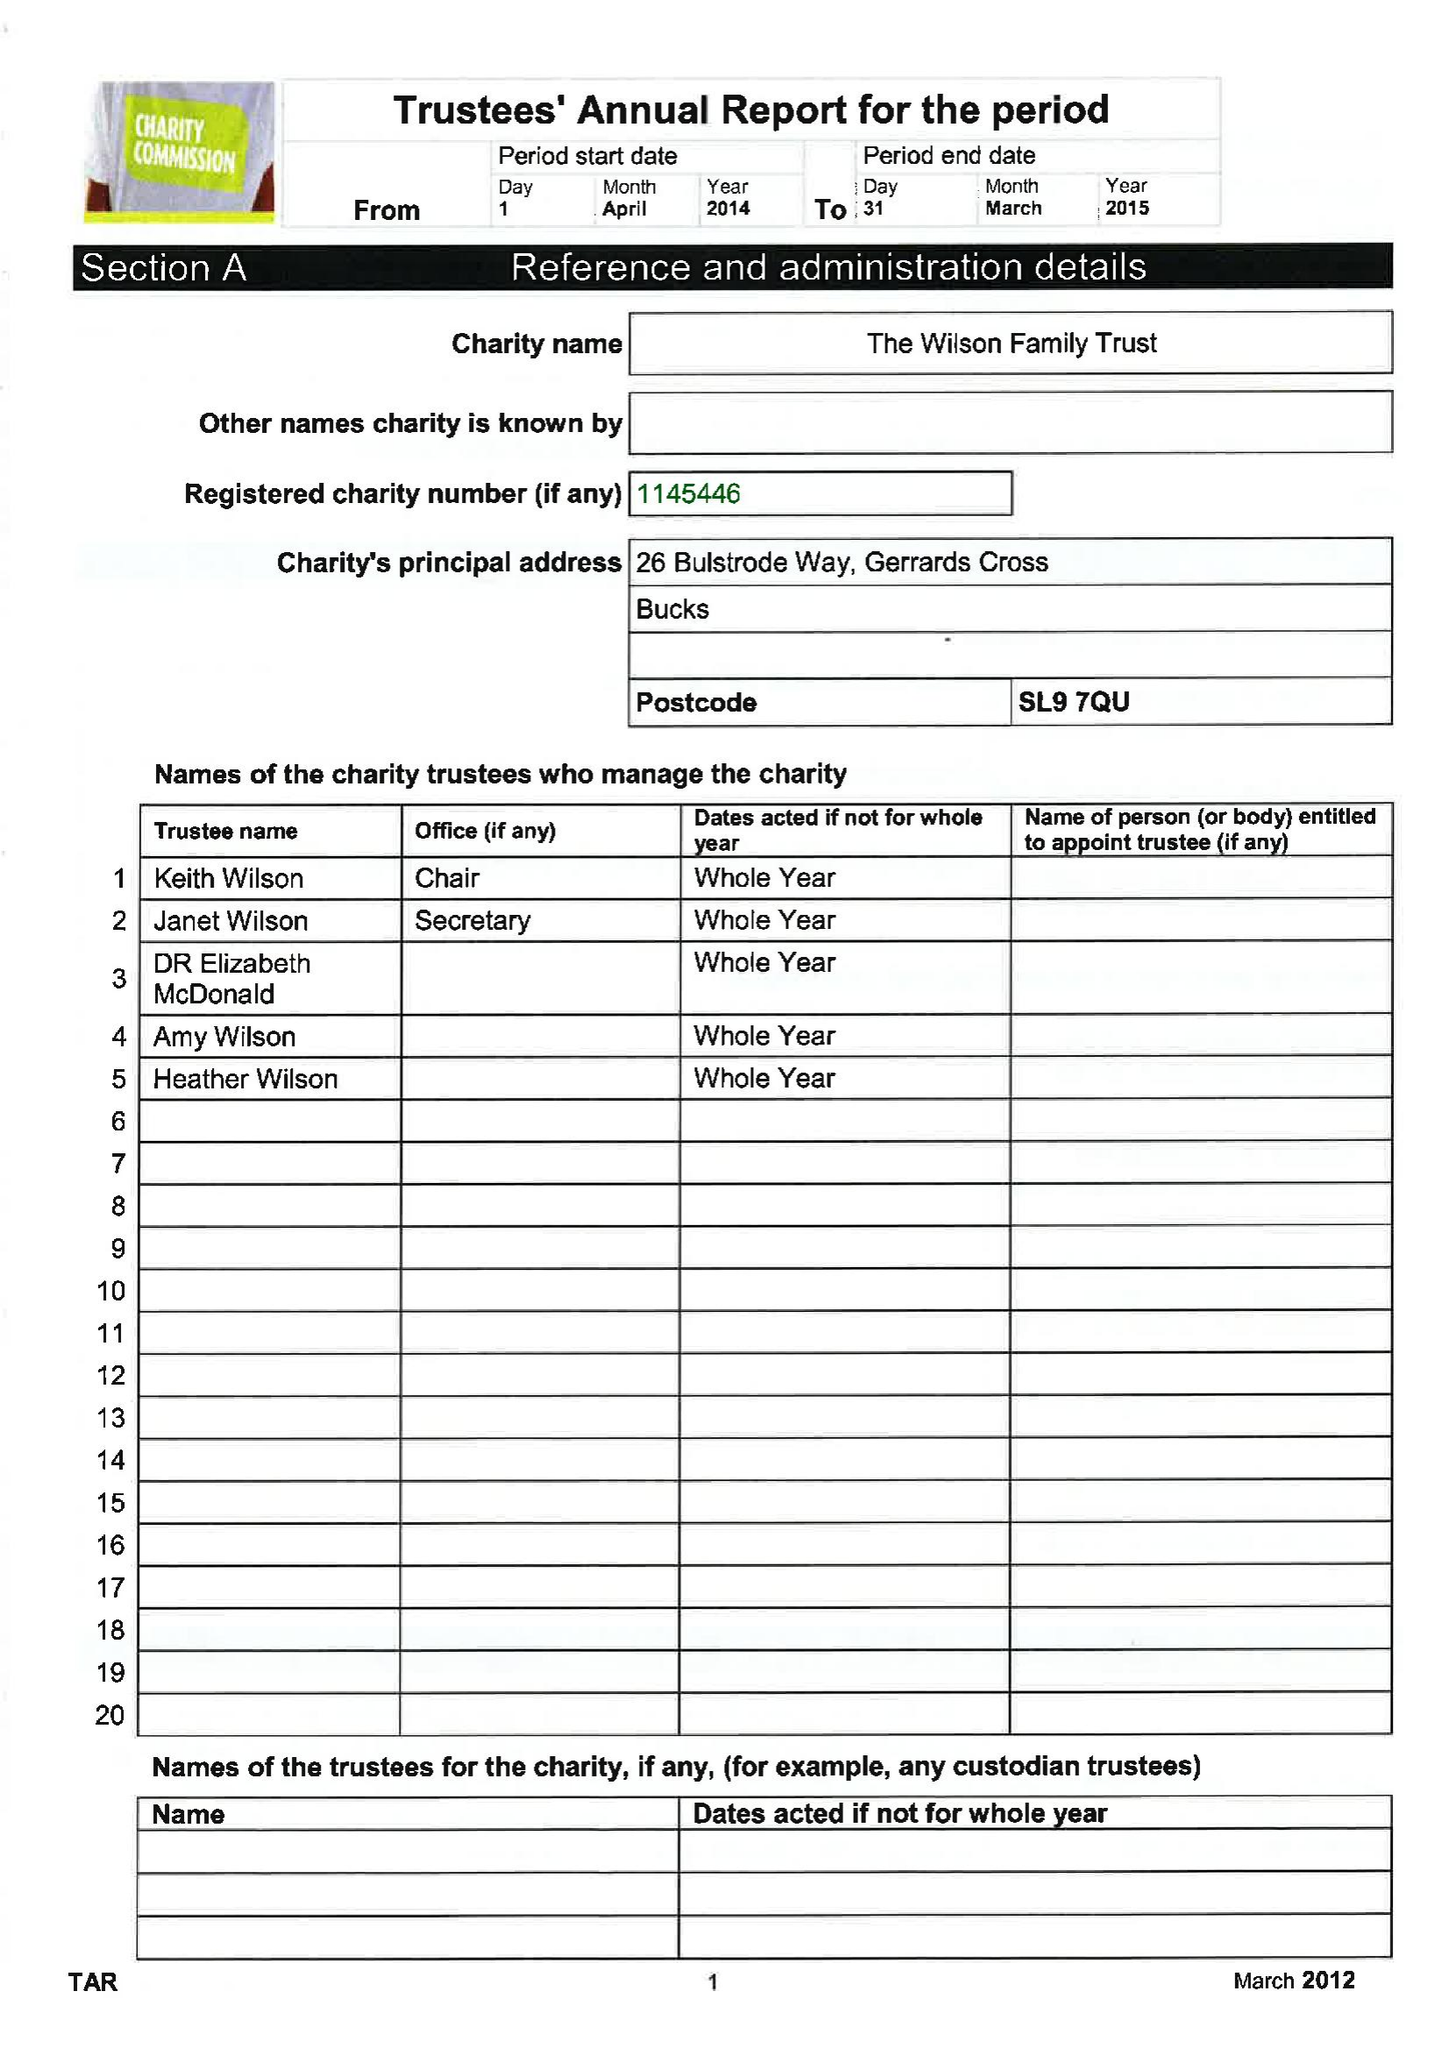What is the value for the address__postcode?
Answer the question using a single word or phrase. SL9 7QU 